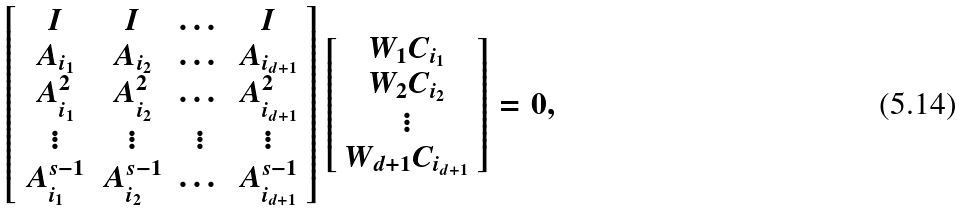<formula> <loc_0><loc_0><loc_500><loc_500>\left [ \begin{array} { c c c c } I & I & \dots & I \\ A _ { i _ { 1 } } & A _ { i _ { 2 } } & \dots & A _ { i _ { d + 1 } } \\ A _ { i _ { 1 } } ^ { 2 } & A _ { i _ { 2 } } ^ { 2 } & \dots & A _ { i _ { d + 1 } } ^ { 2 } \\ \vdots & \vdots & \vdots & \vdots \\ A _ { i _ { 1 } } ^ { s - 1 } & A _ { i _ { 2 } } ^ { s - 1 } & \dots & A _ { i _ { d + 1 } } ^ { s - 1 } \end{array} \right ] \left [ \begin{array} { c } W _ { 1 } C _ { i _ { 1 } } \\ W _ { 2 } C _ { i _ { 2 } } \\ \vdots \\ W _ { d + 1 } C _ { i _ { d + 1 } } \end{array} \right ] = 0 ,</formula> 